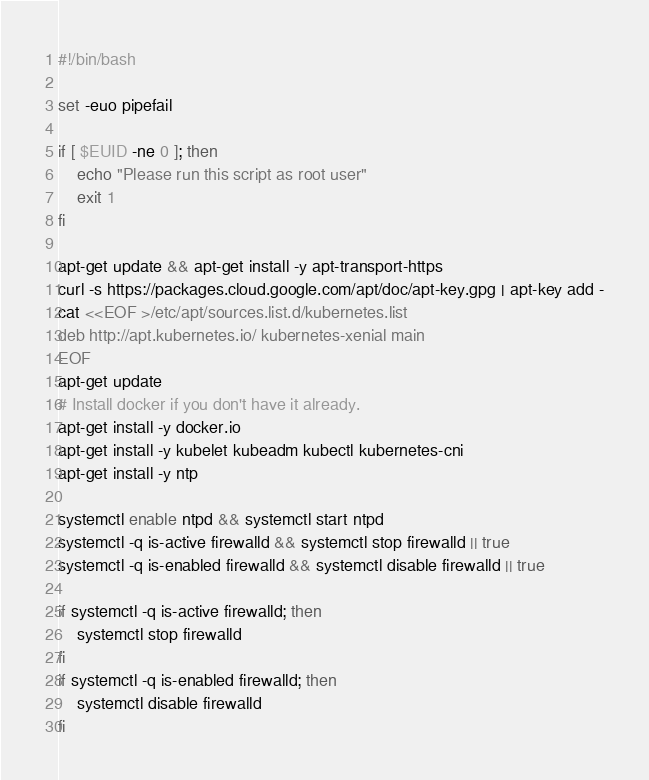Convert code to text. <code><loc_0><loc_0><loc_500><loc_500><_Bash_>#!/bin/bash

set -euo pipefail

if [ $EUID -ne 0 ]; then
	echo "Please run this script as root user"
	exit 1
fi

apt-get update && apt-get install -y apt-transport-https
curl -s https://packages.cloud.google.com/apt/doc/apt-key.gpg | apt-key add -
cat <<EOF >/etc/apt/sources.list.d/kubernetes.list
deb http://apt.kubernetes.io/ kubernetes-xenial main
EOF
apt-get update
# Install docker if you don't have it already.
apt-get install -y docker.io
apt-get install -y kubelet kubeadm kubectl kubernetes-cni
apt-get install -y ntp

systemctl enable ntpd && systemctl start ntpd
systemctl -q is-active firewalld && systemctl stop firewalld || true
systemctl -q is-enabled firewalld && systemctl disable firewalld || true

if systemctl -q is-active firewalld; then
	systemctl stop firewalld
fi
if systemctl -q is-enabled firewalld; then
	systemctl disable firewalld
fi
</code> 